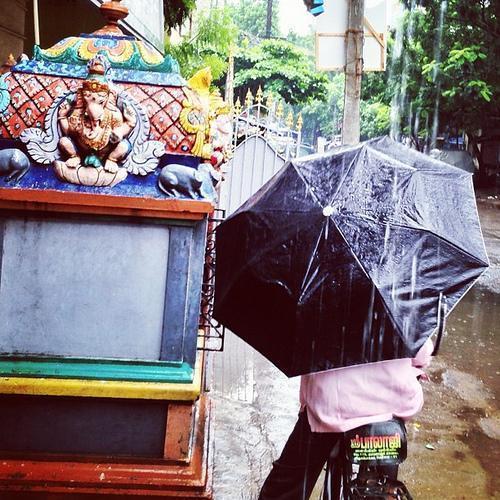How many people are shown?
Give a very brief answer. 1. 